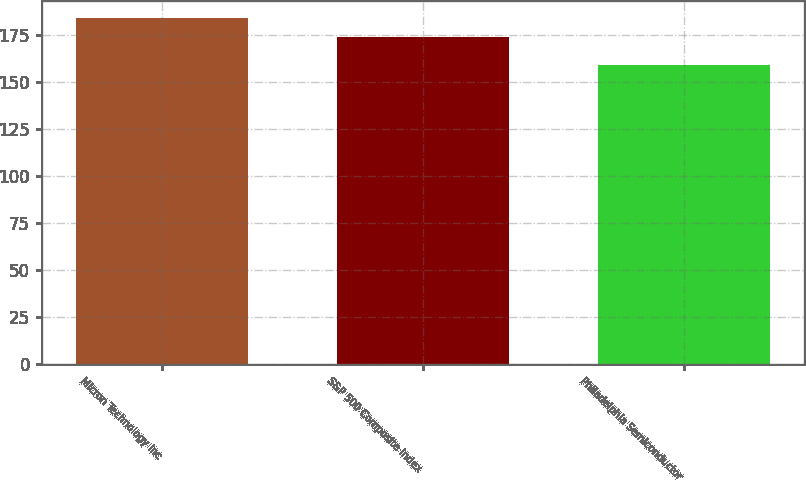<chart> <loc_0><loc_0><loc_500><loc_500><bar_chart><fcel>Micron Technology Inc<fcel>S&P 500 Composite Index<fcel>Philadelphia Semiconductor<nl><fcel>184<fcel>174<fcel>159<nl></chart> 